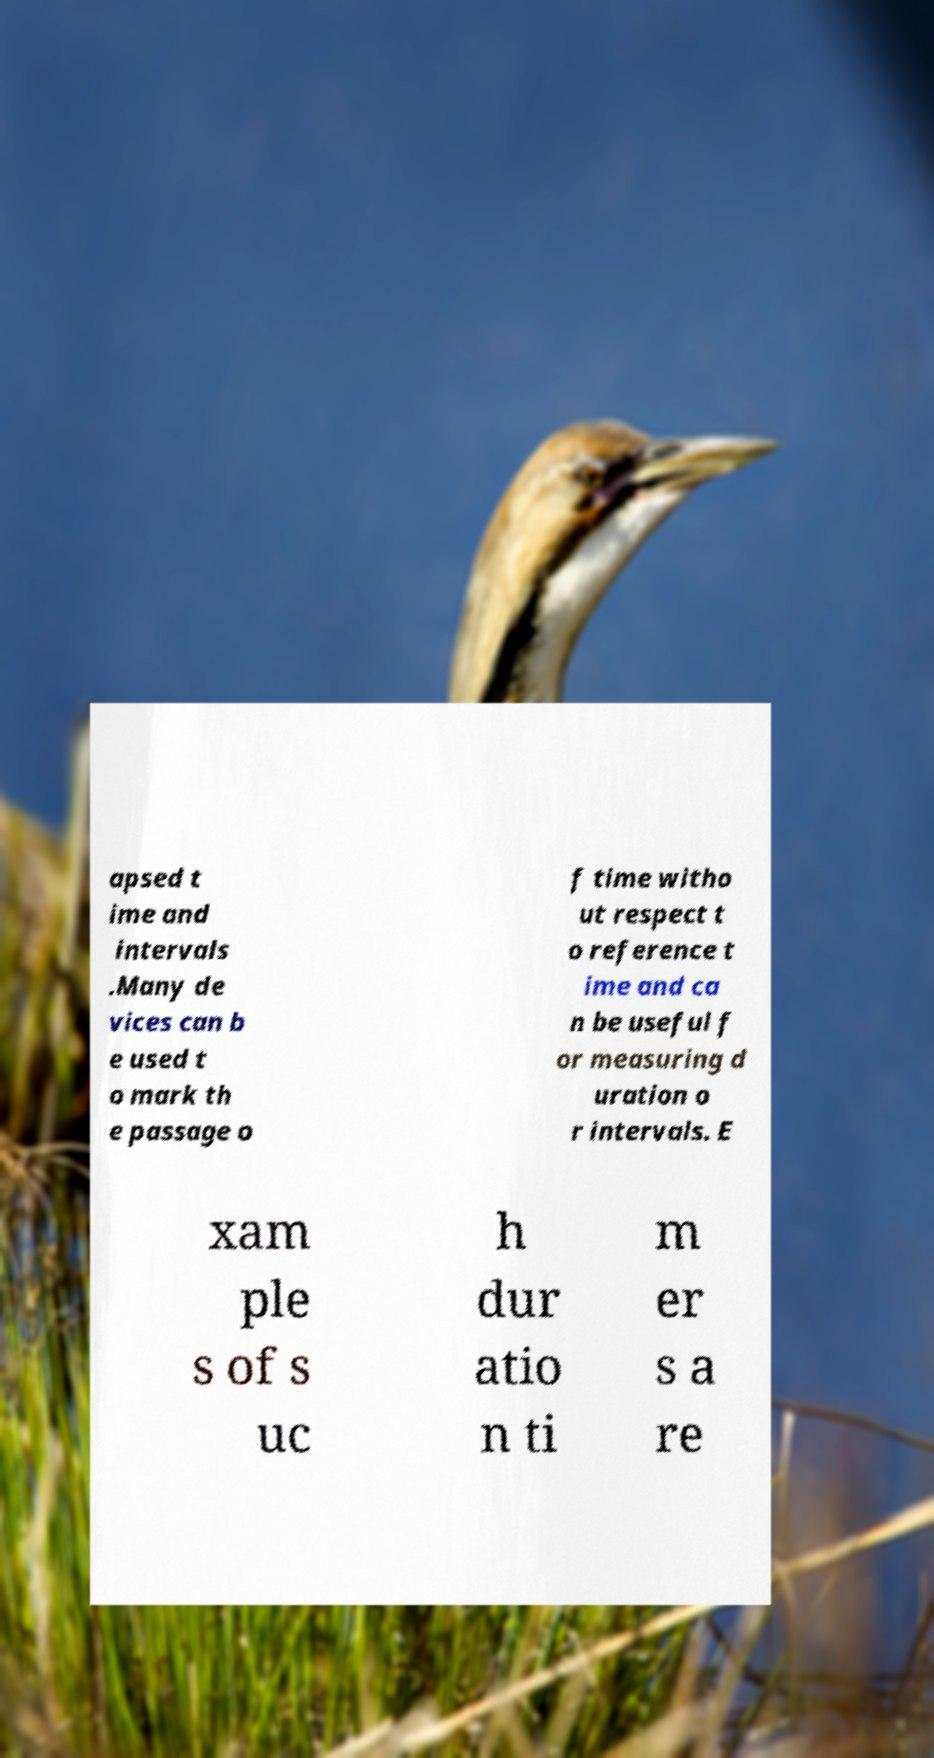What messages or text are displayed in this image? I need them in a readable, typed format. apsed t ime and intervals .Many de vices can b e used t o mark th e passage o f time witho ut respect t o reference t ime and ca n be useful f or measuring d uration o r intervals. E xam ple s of s uc h dur atio n ti m er s a re 